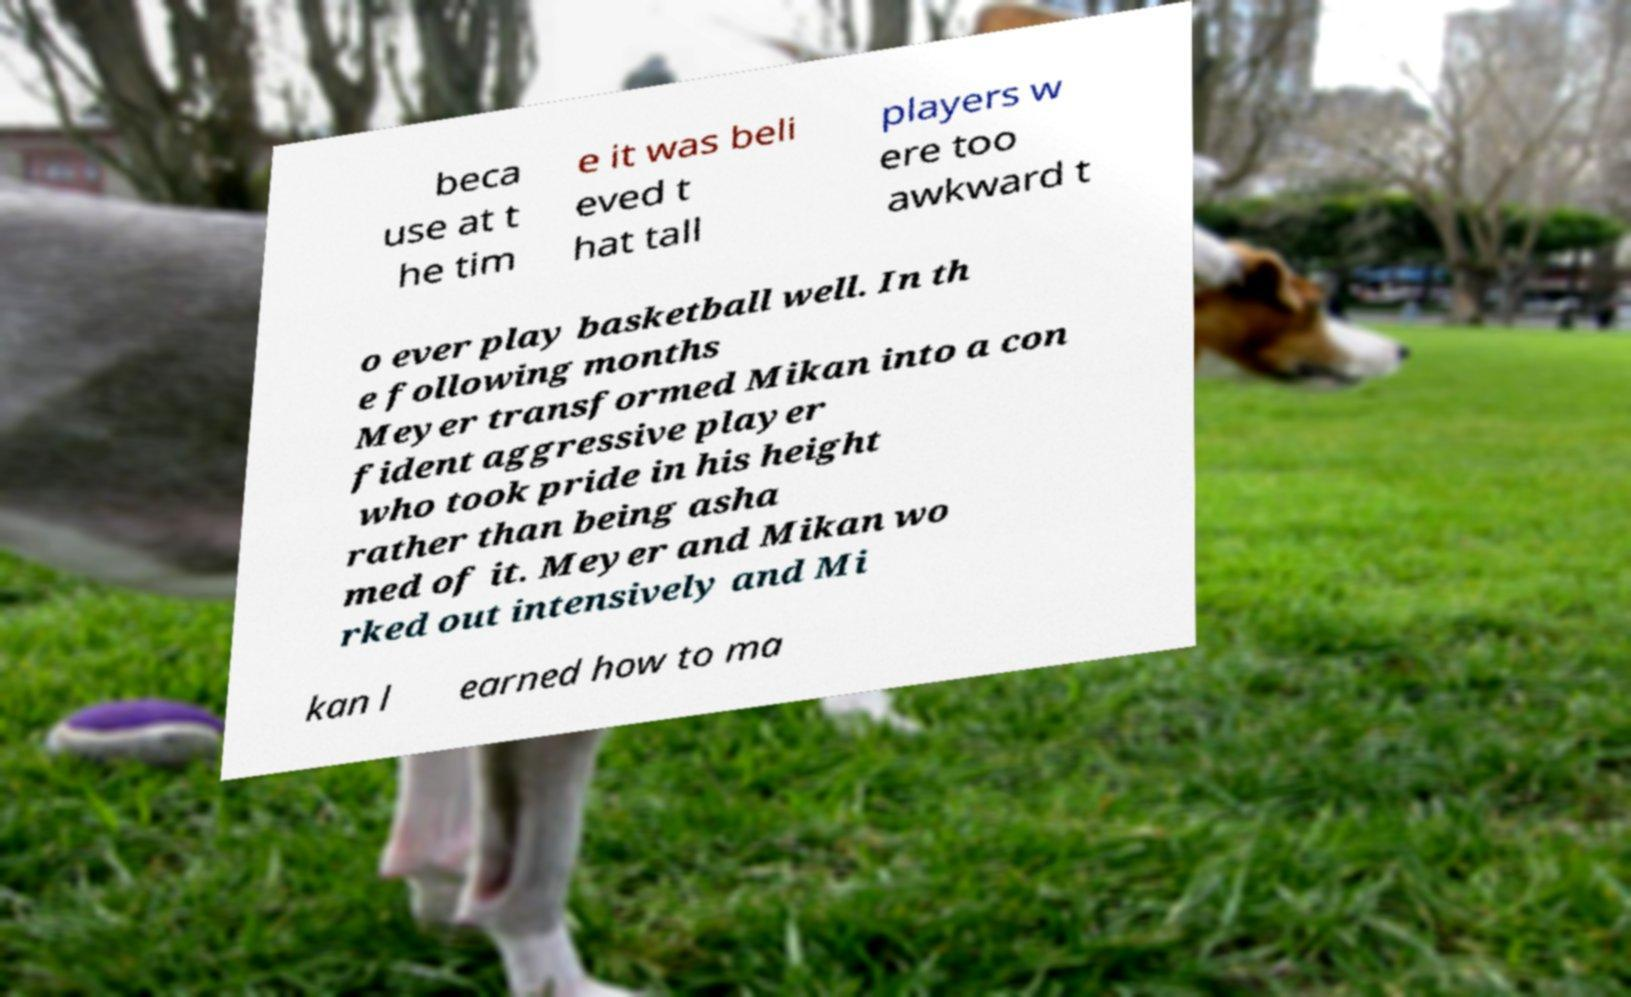Could you assist in decoding the text presented in this image and type it out clearly? beca use at t he tim e it was beli eved t hat tall players w ere too awkward t o ever play basketball well. In th e following months Meyer transformed Mikan into a con fident aggressive player who took pride in his height rather than being asha med of it. Meyer and Mikan wo rked out intensively and Mi kan l earned how to ma 